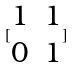<formula> <loc_0><loc_0><loc_500><loc_500>[ \begin{matrix} 1 & 1 \\ 0 & 1 \end{matrix} ]</formula> 